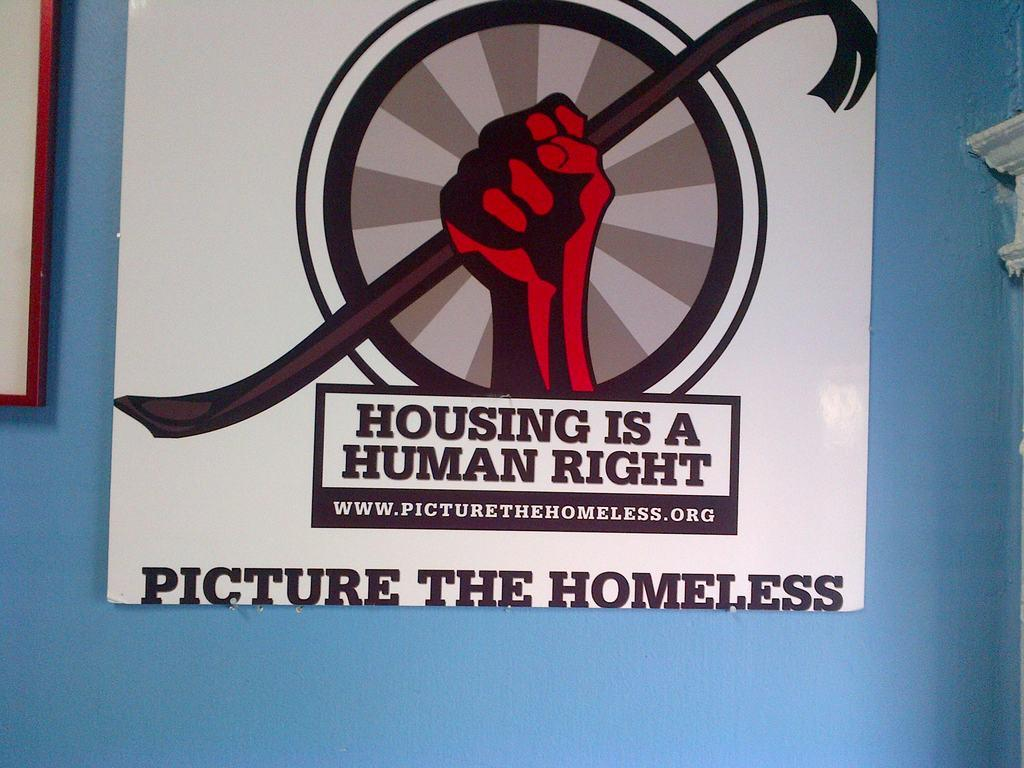What is present on the blue wall in the image? There is a poster on the blue wall in the image. What can be observed about the wall itself? The wall is blue. What is depicted on the poster? There is a hand and a logo on the poster. Are there any words on the poster? Yes, there is writing on the poster. What type of vest is the hand wearing in the image? There is no hand wearing a vest in the image, as the hand depicted on the poster is not wearing any clothing. 